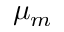Convert formula to latex. <formula><loc_0><loc_0><loc_500><loc_500>\mu _ { m }</formula> 